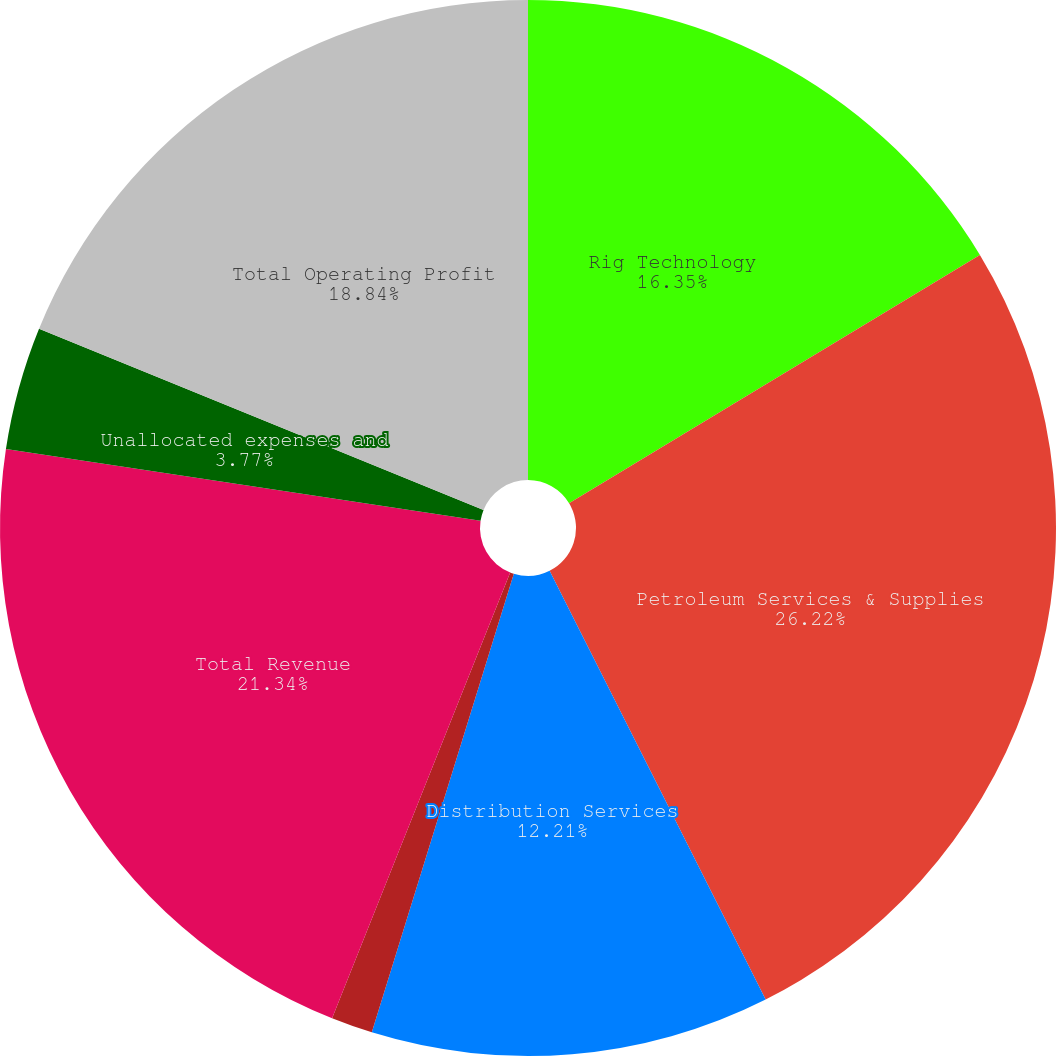Convert chart. <chart><loc_0><loc_0><loc_500><loc_500><pie_chart><fcel>Rig Technology<fcel>Petroleum Services & Supplies<fcel>Distribution Services<fcel>Eliminations<fcel>Total Revenue<fcel>Unallocated expenses and<fcel>Total Operating Profit<nl><fcel>16.35%<fcel>26.22%<fcel>12.21%<fcel>1.27%<fcel>21.34%<fcel>3.77%<fcel>18.84%<nl></chart> 